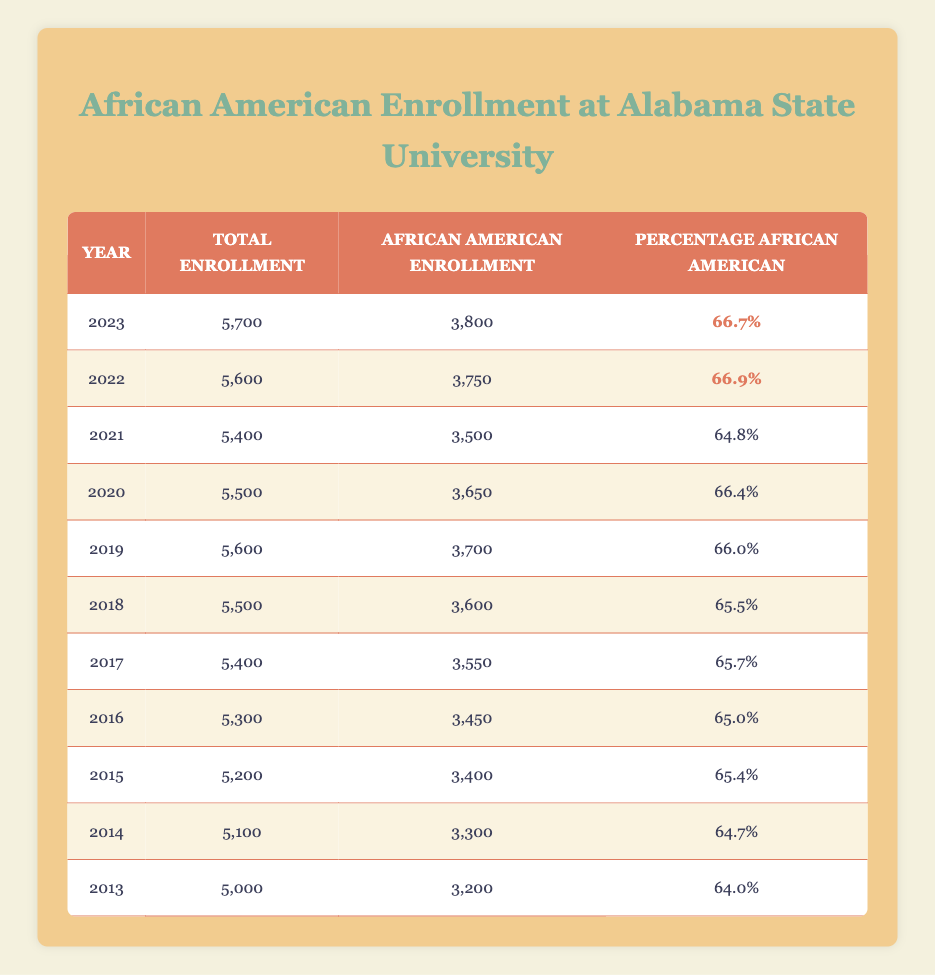What was the total enrollment of African American students at Alabama State University in 2019? The table states that in 2019, the total enrollment was 5,600. We can directly find this value in the row for the year 2019.
Answer: 5,600 In which year did Alabama State University have the highest percentage of African American enrollment? By examining the last column of the table, we can see that in 2022, the percentage of African American enrollment was 66.9%, which is the highest value in the data.
Answer: 2022 What is the average percentage of African American enrollment over the last decade? To calculate the average, we add all the percentages from 2013 to 2023, which adds up to 655.2, and then divide by 11 (the number of years) to find the average. The calculation is 655.2 / 11 = 59.5727272727, which we can round to 59.57%.
Answer: 59.57% Did the total enrollment of African American students increase from 2013 to 2023? In 2013, the total enrollment was 5,000, and in 2023, it was 5,700. Since 5,700 is greater than 5,000, we conclude that there was indeed an increase in total enrollment over the decade.
Answer: Yes What percentage of the total enrollment was African American in 2021? According to the table, the percentage of African American enrollment in 2021 was 64.8%. This figure is found directly in the row for 2021 in the last column.
Answer: 64.8% How many more African American students were enrolled in 2020 compared to 2021? The enrollment figures show that in 2020 there were 3,650 African American students, while in 2021 there were 3,500. To find the difference, we subtract 3,500 from 3,650, resulting in 150 more students in 2020 compared to 2021.
Answer: 150 What was the trend in African American enrollment from 2013 to 2023? By inspecting the African American enrollment numbers from 2013 to 2023, we can see a general upward trend, with the enrollment increasing from 3,200 to 3,800 over the decade, indicating consistent growth.
Answer: Upward trend Was the total enrollment in 2016 higher than that in 2014? In 2016, the total enrollment was 5,300, and in 2014 it was 5,100. Since 5,300 is greater than 5,100, it shows that the total enrollment in 2016 was higher than in 2014.
Answer: Yes What is the difference in total enrollment between the years 2015 and 2017? From the table, total enrollment in 2015 was 5,200, while in 2017 it was 5,400. We can calculate the difference by subtracting 5,200 from 5,400, resulting in a difference of 200.
Answer: 200 What year had a decrease in African American enrollment despite an increase in total enrollment? The year 2021 had an African American enrollment of 3,500, which is lower than the previous year (2020) with 3,650, even though the total enrollment in 2021 was 5,400 compared to 5,500 in 2020. This indicates the enrollment decreased despite total enrollment increasing.
Answer: 2021 